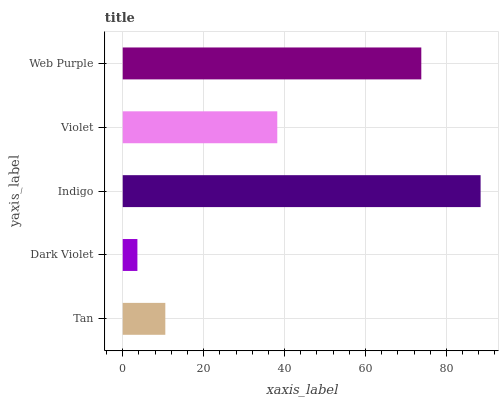Is Dark Violet the minimum?
Answer yes or no. Yes. Is Indigo the maximum?
Answer yes or no. Yes. Is Indigo the minimum?
Answer yes or no. No. Is Dark Violet the maximum?
Answer yes or no. No. Is Indigo greater than Dark Violet?
Answer yes or no. Yes. Is Dark Violet less than Indigo?
Answer yes or no. Yes. Is Dark Violet greater than Indigo?
Answer yes or no. No. Is Indigo less than Dark Violet?
Answer yes or no. No. Is Violet the high median?
Answer yes or no. Yes. Is Violet the low median?
Answer yes or no. Yes. Is Indigo the high median?
Answer yes or no. No. Is Dark Violet the low median?
Answer yes or no. No. 